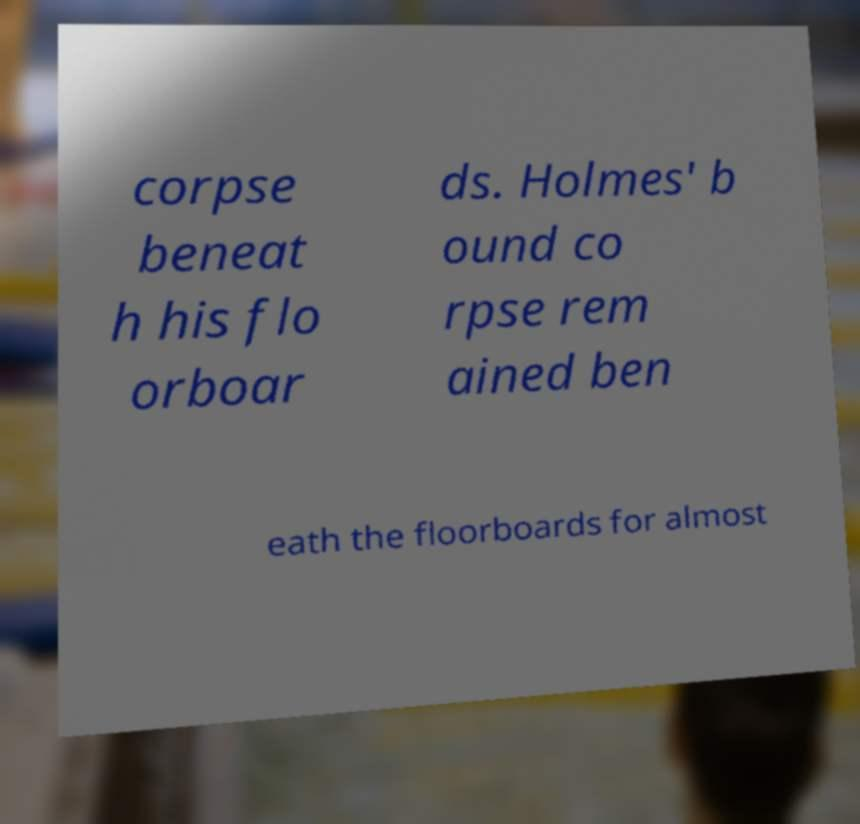Please identify and transcribe the text found in this image. corpse beneat h his flo orboar ds. Holmes' b ound co rpse rem ained ben eath the floorboards for almost 